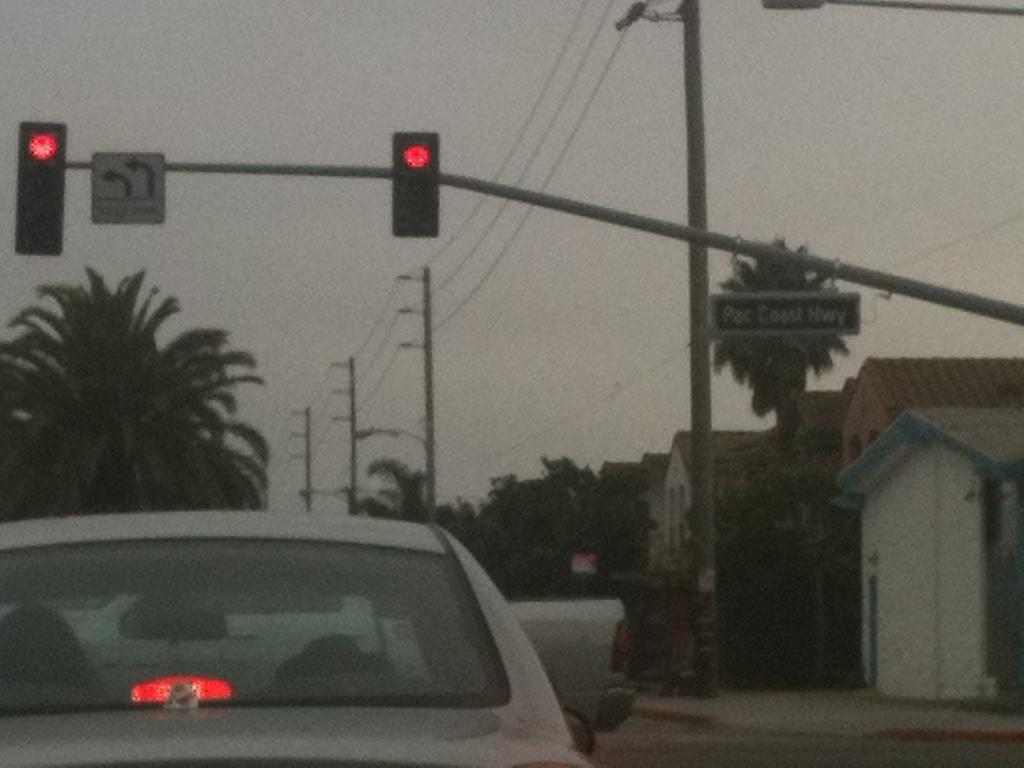<image>
Share a concise interpretation of the image provided. A car is sitting at a red light at the intersection of Pac Coast Hwy. 